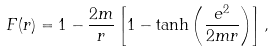Convert formula to latex. <formula><loc_0><loc_0><loc_500><loc_500>F ( r ) = 1 - \frac { 2 m } { r } \left [ 1 - \tanh \left ( \frac { e ^ { 2 } } { 2 m r } \right ) \right ] ,</formula> 